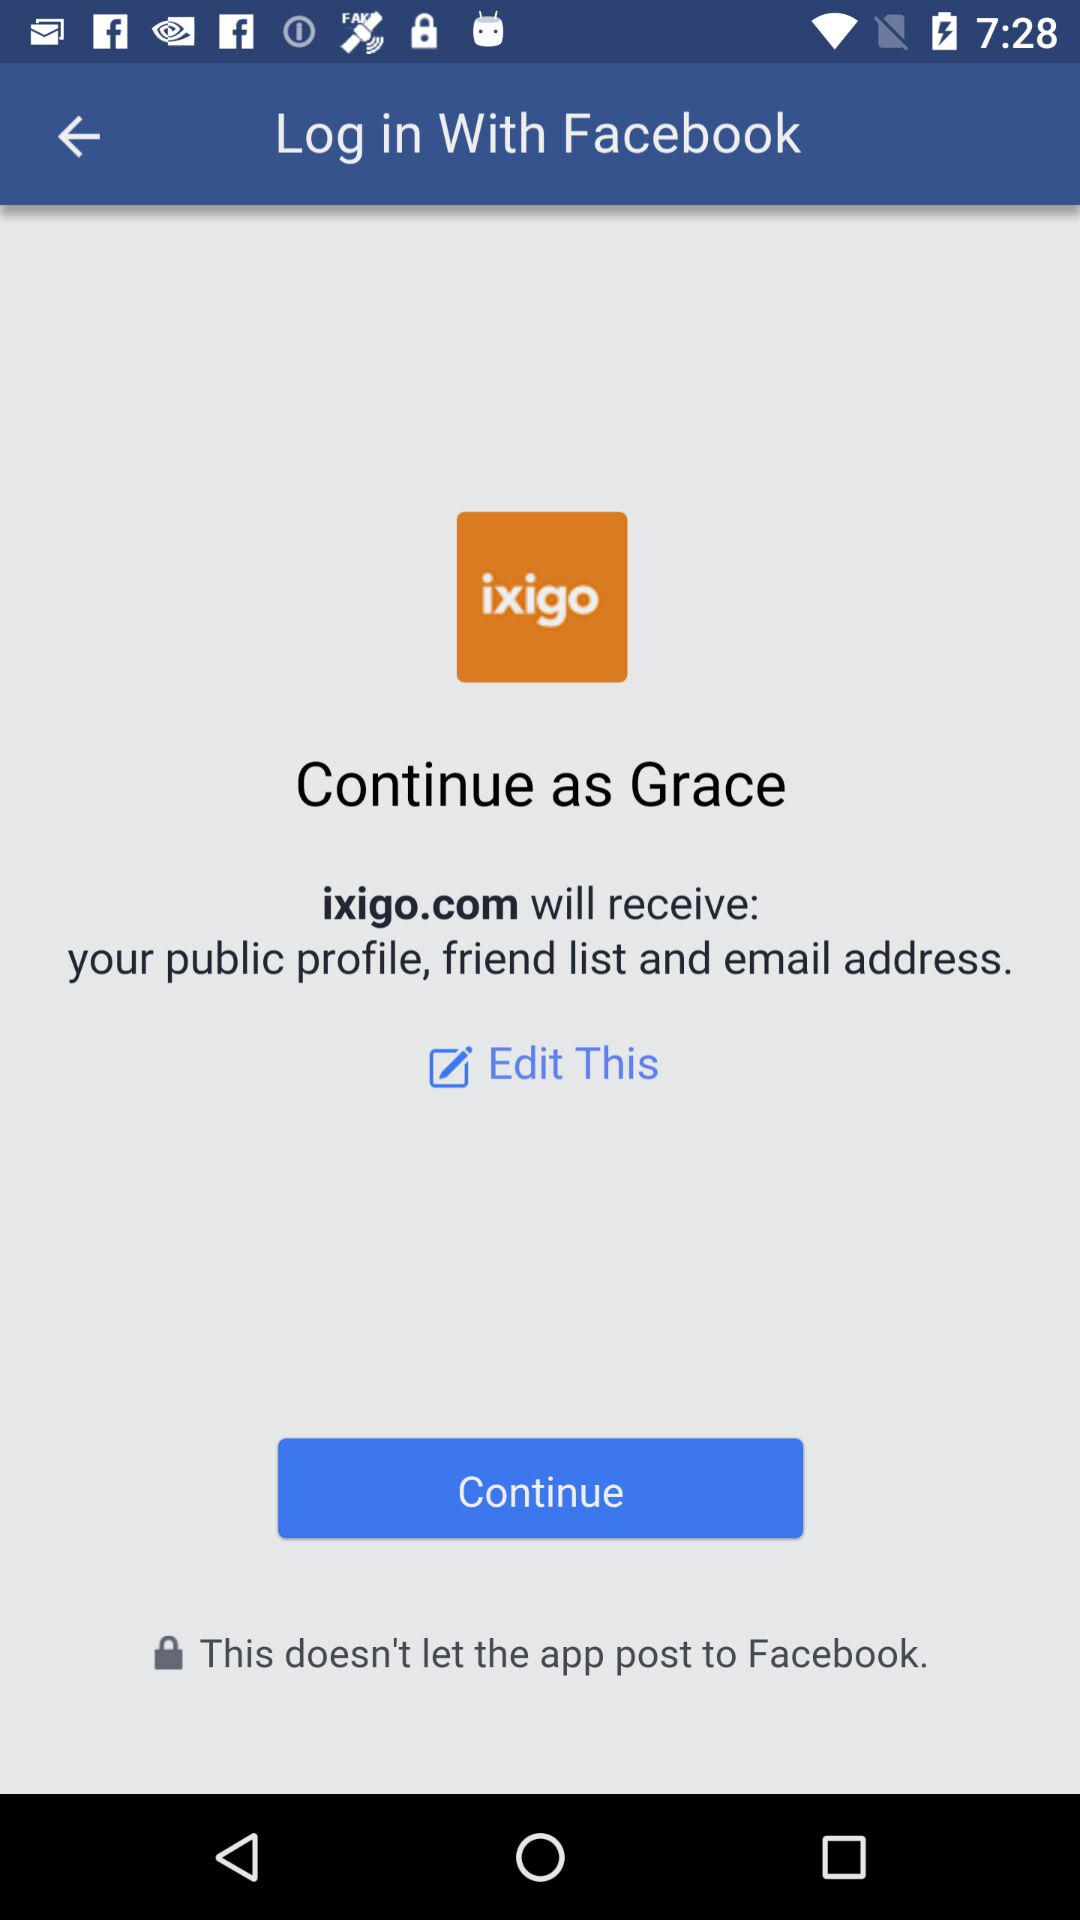Who will receive the public figure, friend list, and email address? The public figure, friend list, and email address will be received by "ixigo.com". 